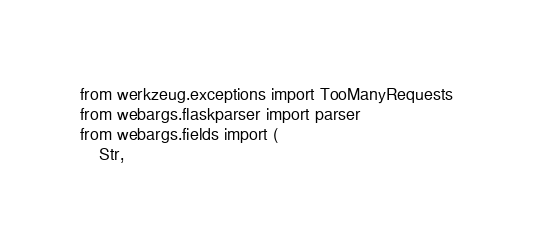<code> <loc_0><loc_0><loc_500><loc_500><_Python_>from werkzeug.exceptions import TooManyRequests
from webargs.flaskparser import parser
from webargs.fields import (
    Str,</code> 